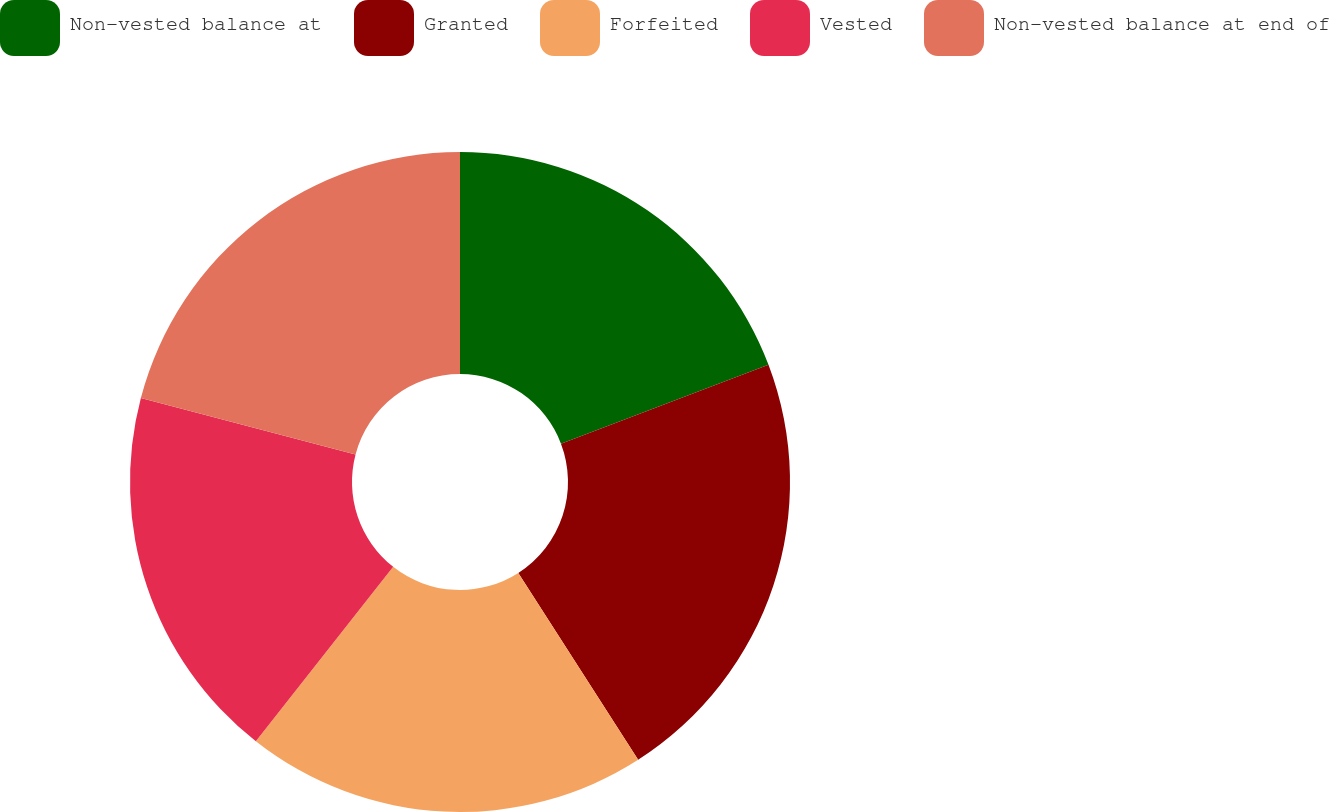Convert chart. <chart><loc_0><loc_0><loc_500><loc_500><pie_chart><fcel>Non-vested balance at<fcel>Granted<fcel>Forfeited<fcel>Vested<fcel>Non-vested balance at end of<nl><fcel>19.22%<fcel>21.7%<fcel>19.69%<fcel>18.48%<fcel>20.9%<nl></chart> 